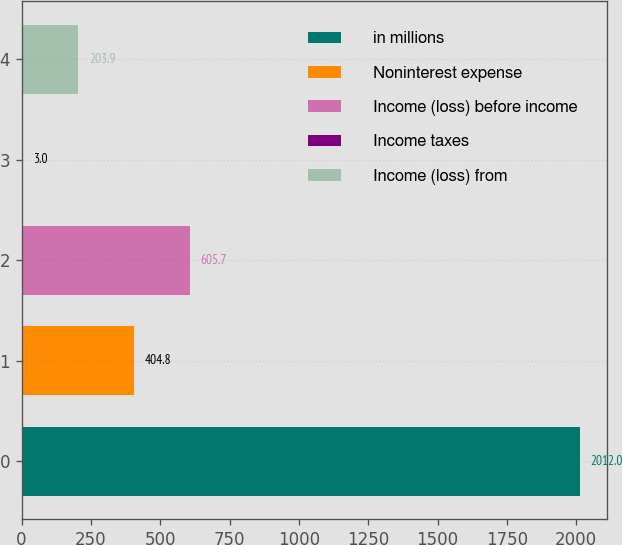Convert chart to OTSL. <chart><loc_0><loc_0><loc_500><loc_500><bar_chart><fcel>in millions<fcel>Noninterest expense<fcel>Income (loss) before income<fcel>Income taxes<fcel>Income (loss) from<nl><fcel>2012<fcel>404.8<fcel>605.7<fcel>3<fcel>203.9<nl></chart> 